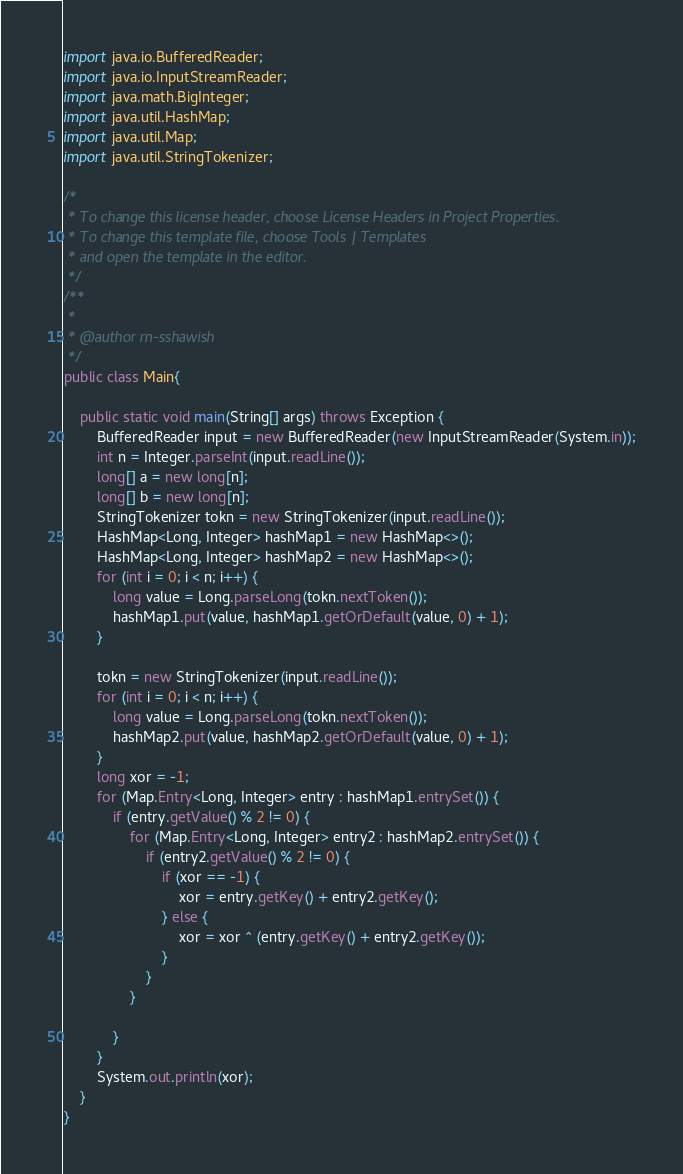<code> <loc_0><loc_0><loc_500><loc_500><_Java_>
import java.io.BufferedReader;
import java.io.InputStreamReader;
import java.math.BigInteger;
import java.util.HashMap;
import java.util.Map;
import java.util.StringTokenizer;

/*
 * To change this license header, choose License Headers in Project Properties.
 * To change this template file, choose Tools | Templates
 * and open the template in the editor.
 */
/**
 *
 * @author rn-sshawish
 */
public class Main{

    public static void main(String[] args) throws Exception {
        BufferedReader input = new BufferedReader(new InputStreamReader(System.in));
        int n = Integer.parseInt(input.readLine());
        long[] a = new long[n];
        long[] b = new long[n];
        StringTokenizer tokn = new StringTokenizer(input.readLine());
        HashMap<Long, Integer> hashMap1 = new HashMap<>();
        HashMap<Long, Integer> hashMap2 = new HashMap<>();
        for (int i = 0; i < n; i++) {
            long value = Long.parseLong(tokn.nextToken());
            hashMap1.put(value, hashMap1.getOrDefault(value, 0) + 1);
        }

        tokn = new StringTokenizer(input.readLine());
        for (int i = 0; i < n; i++) {
            long value = Long.parseLong(tokn.nextToken());
            hashMap2.put(value, hashMap2.getOrDefault(value, 0) + 1);
        }
        long xor = -1;
        for (Map.Entry<Long, Integer> entry : hashMap1.entrySet()) {
            if (entry.getValue() % 2 != 0) {
                for (Map.Entry<Long, Integer> entry2 : hashMap2.entrySet()) {
                    if (entry2.getValue() % 2 != 0) {
                        if (xor == -1) {
                            xor = entry.getKey() + entry2.getKey();
                        } else {
                            xor = xor ^ (entry.getKey() + entry2.getKey());
                        }
                    }
                }

            }
        }
        System.out.println(xor);
    }
}
</code> 